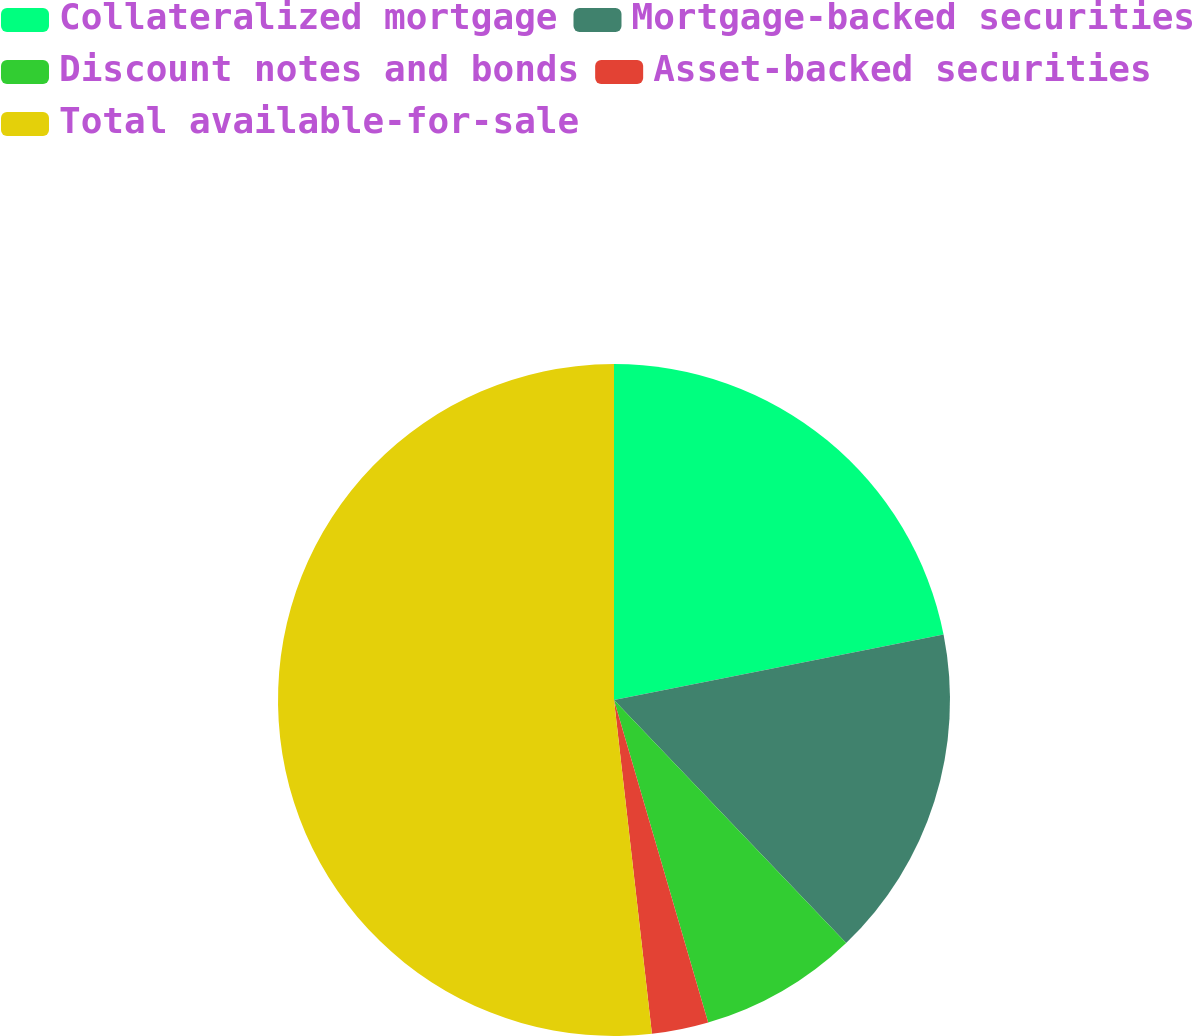Convert chart. <chart><loc_0><loc_0><loc_500><loc_500><pie_chart><fcel>Collateralized mortgage<fcel>Mortgage-backed securities<fcel>Discount notes and bonds<fcel>Asset-backed securities<fcel>Total available-for-sale<nl><fcel>21.88%<fcel>15.98%<fcel>7.62%<fcel>2.72%<fcel>51.8%<nl></chart> 